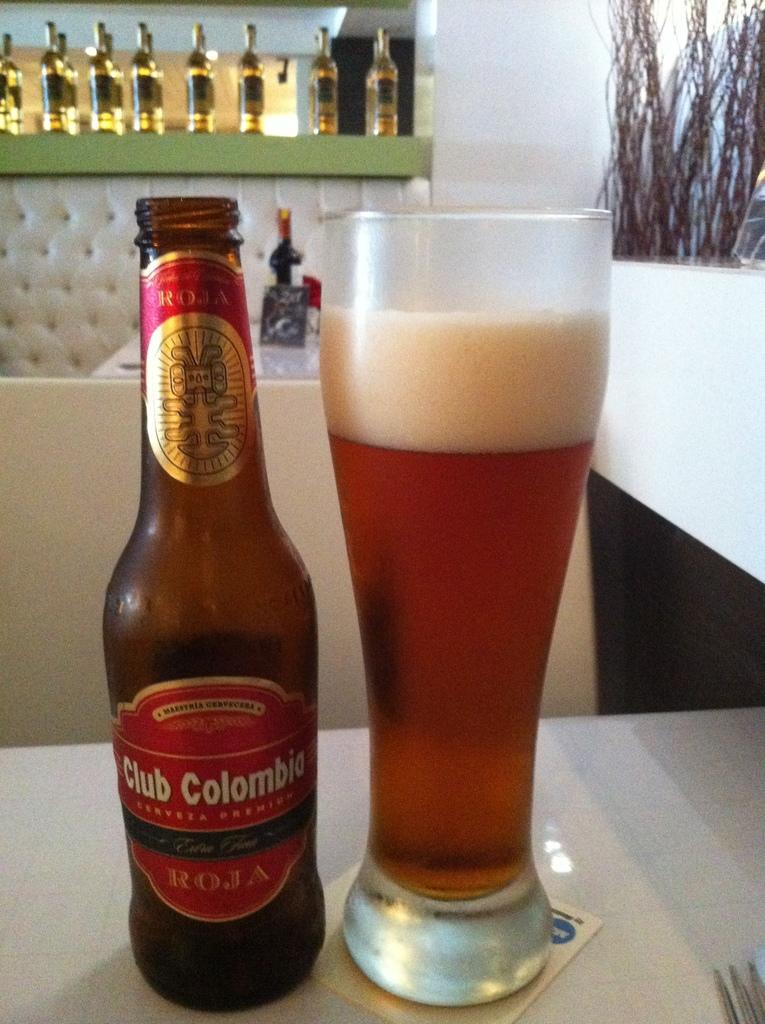<image>
Provide a brief description of the given image. A bottle of Club Colombia is next to a full glass of beer. 